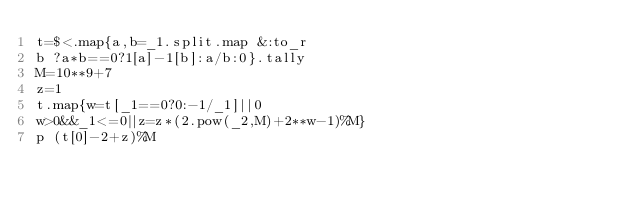<code> <loc_0><loc_0><loc_500><loc_500><_Ruby_>t=$<.map{a,b=_1.split.map &:to_r
b ?a*b==0?1[a]-1[b]:a/b:0}.tally
M=10**9+7
z=1
t.map{w=t[_1==0?0:-1/_1]||0
w>0&&_1<=0||z=z*(2.pow(_2,M)+2**w-1)%M}
p (t[0]-2+z)%M</code> 